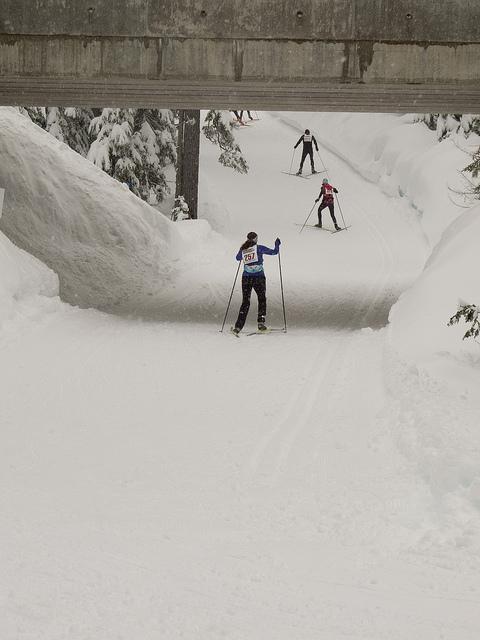What is the person doing?
Answer briefly. Skiing. How many people are skiing?
Give a very brief answer. 3. Are these people all going in the same direction?
Keep it brief. Yes. How deep is the snow?
Answer briefly. Very. How many people are visible?
Write a very short answer. 3. 